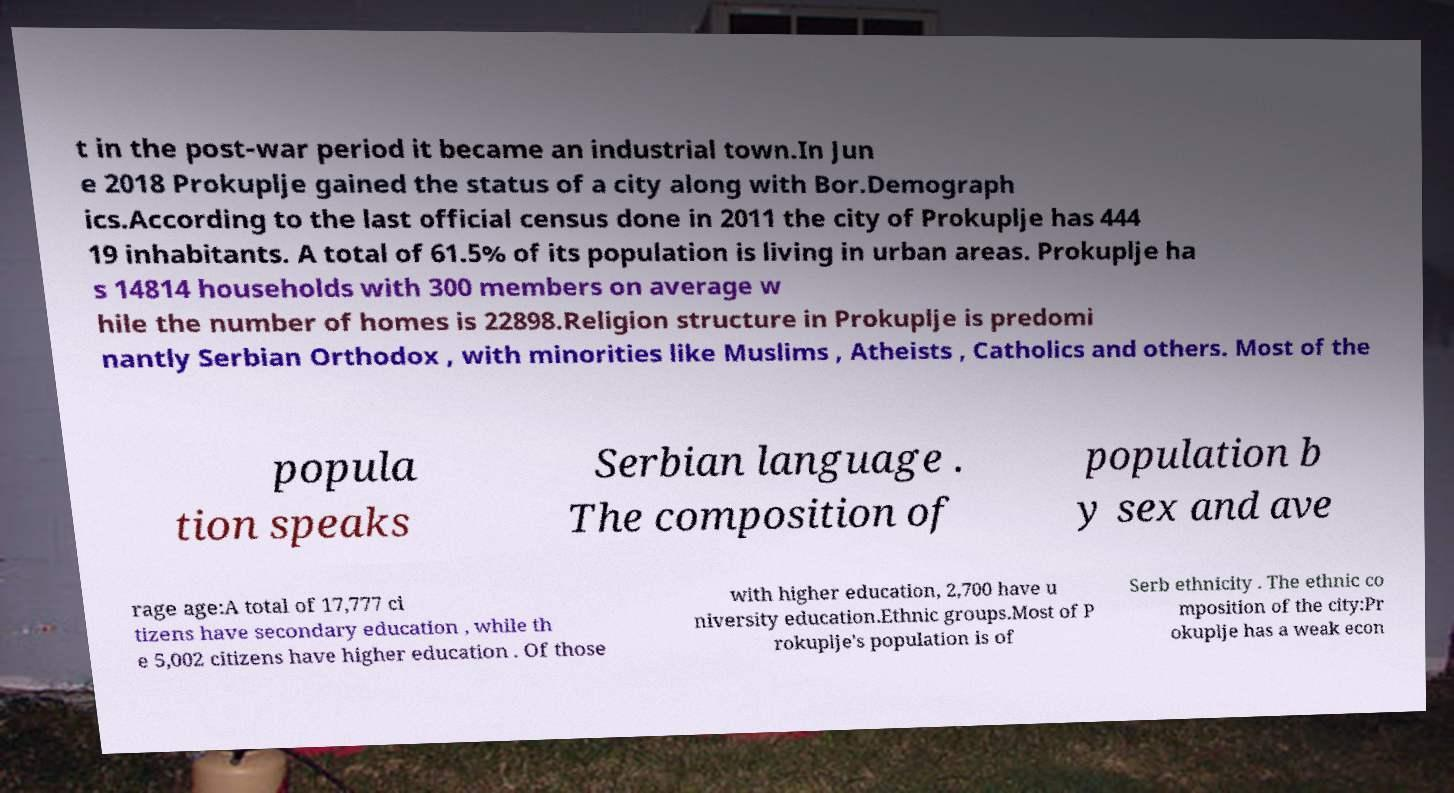Could you assist in decoding the text presented in this image and type it out clearly? t in the post-war period it became an industrial town.In Jun e 2018 Prokuplje gained the status of a city along with Bor.Demograph ics.According to the last official census done in 2011 the city of Prokuplje has 444 19 inhabitants. A total of 61.5% of its population is living in urban areas. Prokuplje ha s 14814 households with 300 members on average w hile the number of homes is 22898.Religion structure in Prokuplje is predomi nantly Serbian Orthodox , with minorities like Muslims , Atheists , Catholics and others. Most of the popula tion speaks Serbian language . The composition of population b y sex and ave rage age:A total of 17,777 ci tizens have secondary education , while th e 5,002 citizens have higher education . Of those with higher education, 2,700 have u niversity education.Ethnic groups.Most of P rokuplje's population is of Serb ethnicity . The ethnic co mposition of the city:Pr okuplje has a weak econ 